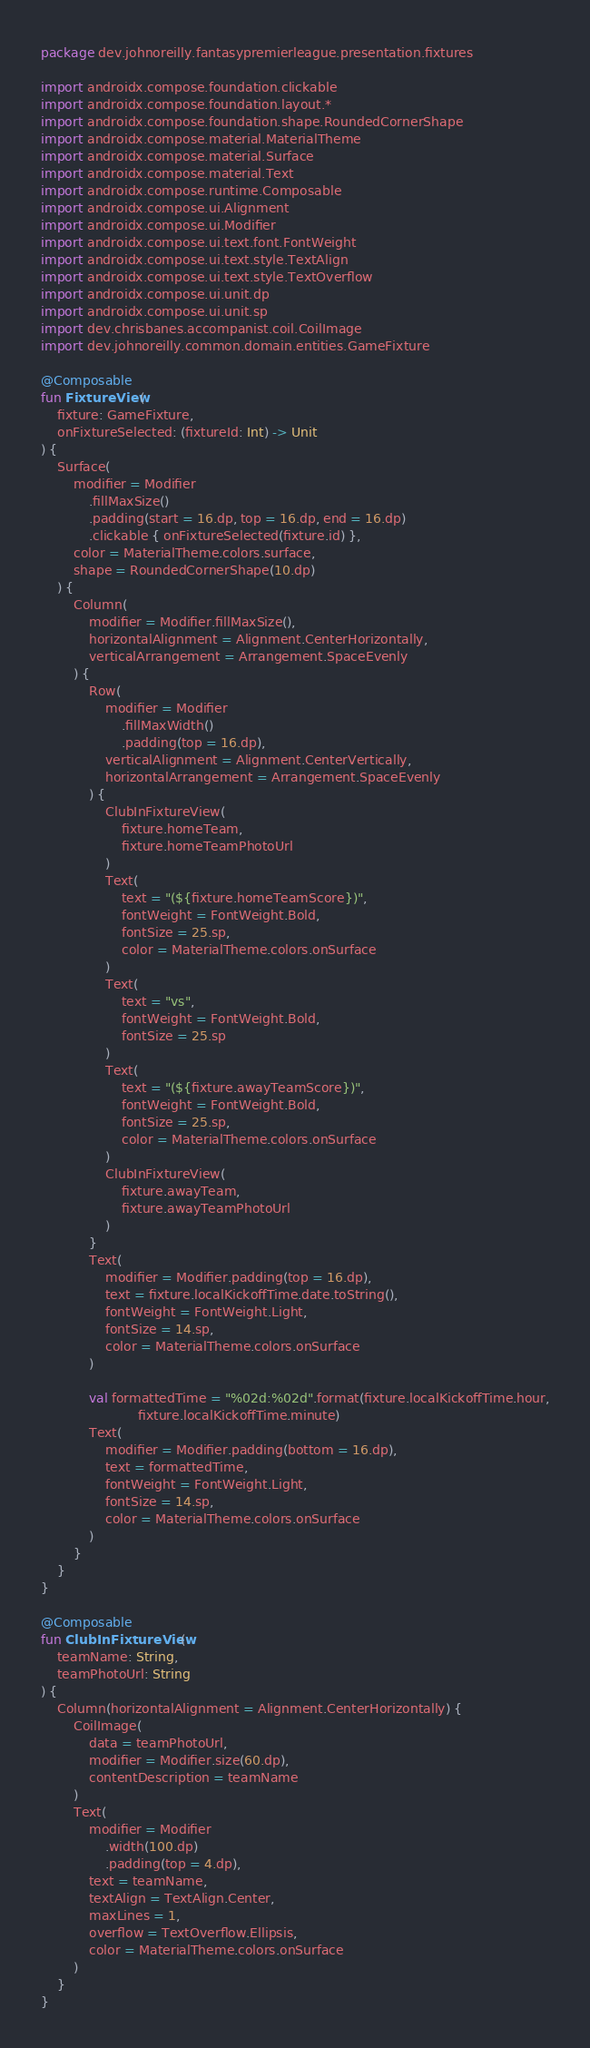<code> <loc_0><loc_0><loc_500><loc_500><_Kotlin_>package dev.johnoreilly.fantasypremierleague.presentation.fixtures

import androidx.compose.foundation.clickable
import androidx.compose.foundation.layout.*
import androidx.compose.foundation.shape.RoundedCornerShape
import androidx.compose.material.MaterialTheme
import androidx.compose.material.Surface
import androidx.compose.material.Text
import androidx.compose.runtime.Composable
import androidx.compose.ui.Alignment
import androidx.compose.ui.Modifier
import androidx.compose.ui.text.font.FontWeight
import androidx.compose.ui.text.style.TextAlign
import androidx.compose.ui.text.style.TextOverflow
import androidx.compose.ui.unit.dp
import androidx.compose.ui.unit.sp
import dev.chrisbanes.accompanist.coil.CoilImage
import dev.johnoreilly.common.domain.entities.GameFixture

@Composable
fun FixtureView(
    fixture: GameFixture,
    onFixtureSelected: (fixtureId: Int) -> Unit
) {
    Surface(
        modifier = Modifier
            .fillMaxSize()
            .padding(start = 16.dp, top = 16.dp, end = 16.dp)
            .clickable { onFixtureSelected(fixture.id) },
        color = MaterialTheme.colors.surface,
        shape = RoundedCornerShape(10.dp)
    ) {
        Column(
            modifier = Modifier.fillMaxSize(),
            horizontalAlignment = Alignment.CenterHorizontally,
            verticalArrangement = Arrangement.SpaceEvenly
        ) {
            Row(
                modifier = Modifier
                    .fillMaxWidth()
                    .padding(top = 16.dp),
                verticalAlignment = Alignment.CenterVertically,
                horizontalArrangement = Arrangement.SpaceEvenly
            ) {
                ClubInFixtureView(
                    fixture.homeTeam,
                    fixture.homeTeamPhotoUrl
                )
                Text(
                    text = "(${fixture.homeTeamScore})",
                    fontWeight = FontWeight.Bold,
                    fontSize = 25.sp,
                    color = MaterialTheme.colors.onSurface
                )
                Text(
                    text = "vs",
                    fontWeight = FontWeight.Bold,
                    fontSize = 25.sp
                )
                Text(
                    text = "(${fixture.awayTeamScore})",
                    fontWeight = FontWeight.Bold,
                    fontSize = 25.sp,
                    color = MaterialTheme.colors.onSurface
                )
                ClubInFixtureView(
                    fixture.awayTeam,
                    fixture.awayTeamPhotoUrl
                )
            }
            Text(
                modifier = Modifier.padding(top = 16.dp),
                text = fixture.localKickoffTime.date.toString(),
                fontWeight = FontWeight.Light,
                fontSize = 14.sp,
                color = MaterialTheme.colors.onSurface
            )

            val formattedTime = "%02d:%02d".format(fixture.localKickoffTime.hour,
                        fixture.localKickoffTime.minute)
            Text(
                modifier = Modifier.padding(bottom = 16.dp),
                text = formattedTime,
                fontWeight = FontWeight.Light,
                fontSize = 14.sp,
                color = MaterialTheme.colors.onSurface
            )
        }
    }
}

@Composable
fun ClubInFixtureView(
    teamName: String,
    teamPhotoUrl: String
) {
    Column(horizontalAlignment = Alignment.CenterHorizontally) {
        CoilImage(
            data = teamPhotoUrl,
            modifier = Modifier.size(60.dp),
            contentDescription = teamName
        )
        Text(
            modifier = Modifier
                .width(100.dp)
                .padding(top = 4.dp),
            text = teamName,
            textAlign = TextAlign.Center,
            maxLines = 1,
            overflow = TextOverflow.Ellipsis,
            color = MaterialTheme.colors.onSurface
        )
    }
}</code> 